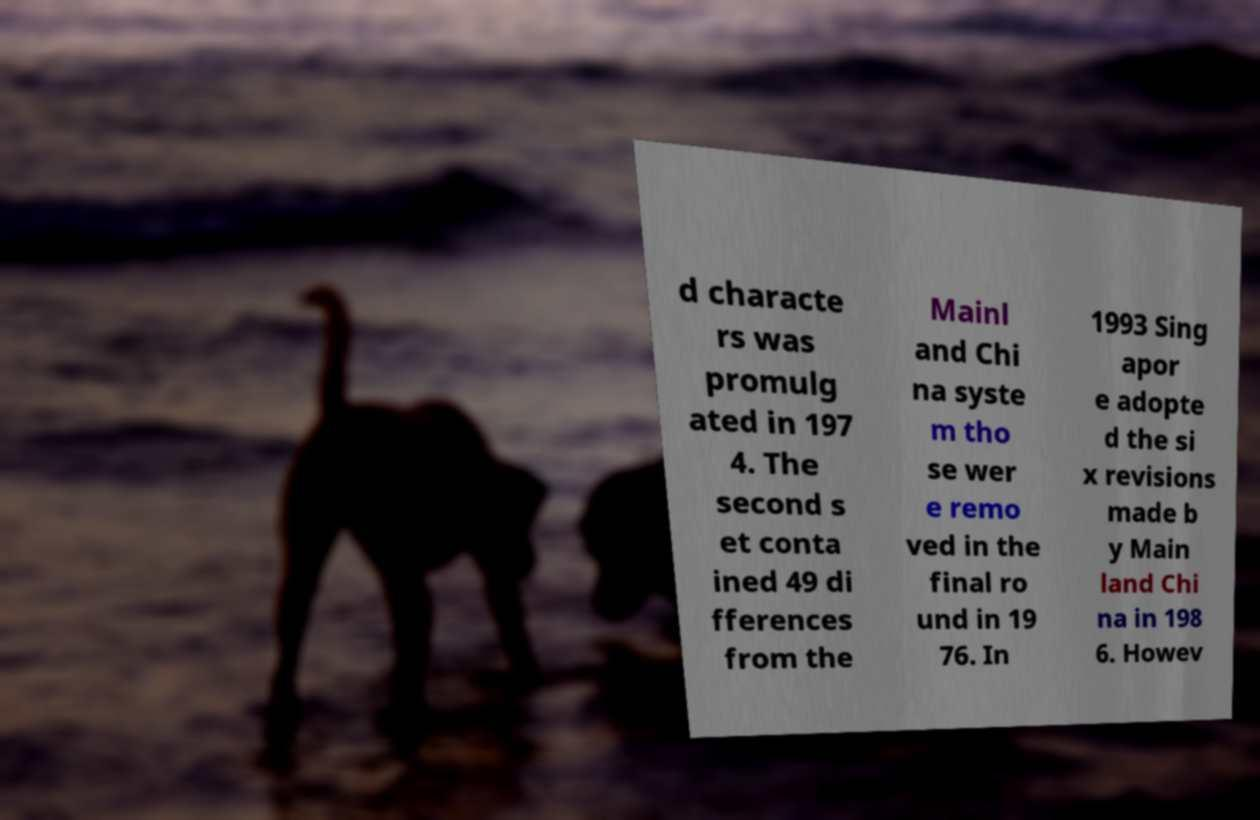Could you assist in decoding the text presented in this image and type it out clearly? d characte rs was promulg ated in 197 4. The second s et conta ined 49 di fferences from the Mainl and Chi na syste m tho se wer e remo ved in the final ro und in 19 76. In 1993 Sing apor e adopte d the si x revisions made b y Main land Chi na in 198 6. Howev 